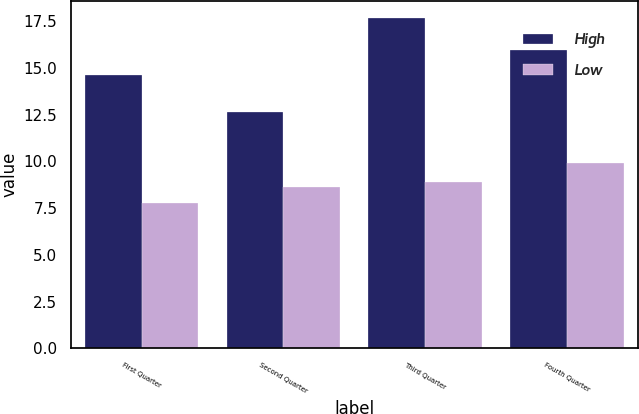Convert chart. <chart><loc_0><loc_0><loc_500><loc_500><stacked_bar_chart><ecel><fcel>First Quarter<fcel>Second Quarter<fcel>Third Quarter<fcel>Fourth Quarter<nl><fcel>High<fcel>14.63<fcel>12.64<fcel>17.7<fcel>15.97<nl><fcel>Low<fcel>7.8<fcel>8.63<fcel>8.88<fcel>9.92<nl></chart> 